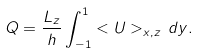Convert formula to latex. <formula><loc_0><loc_0><loc_500><loc_500>Q = \frac { L _ { z } } { h } \int ^ { 1 } _ { - 1 } < U > _ { x , z } \, d y .</formula> 